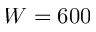Convert formula to latex. <formula><loc_0><loc_0><loc_500><loc_500>W = 6 0 0</formula> 